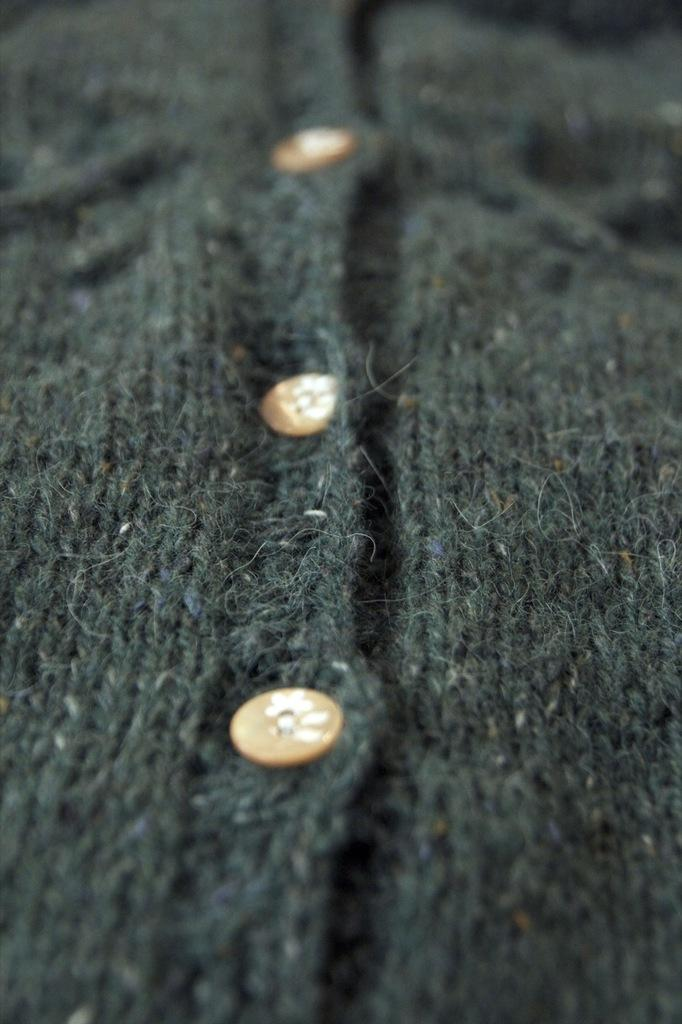What is the main object in the image? There is a cloth in the image. Are there any other notable features in the image? Yes, there are three buttons in the image. What is the opinion of the chalk on the process of buttoning the cloth in the image? There is no chalk present in the image, and therefore no opinion can be attributed to it. 